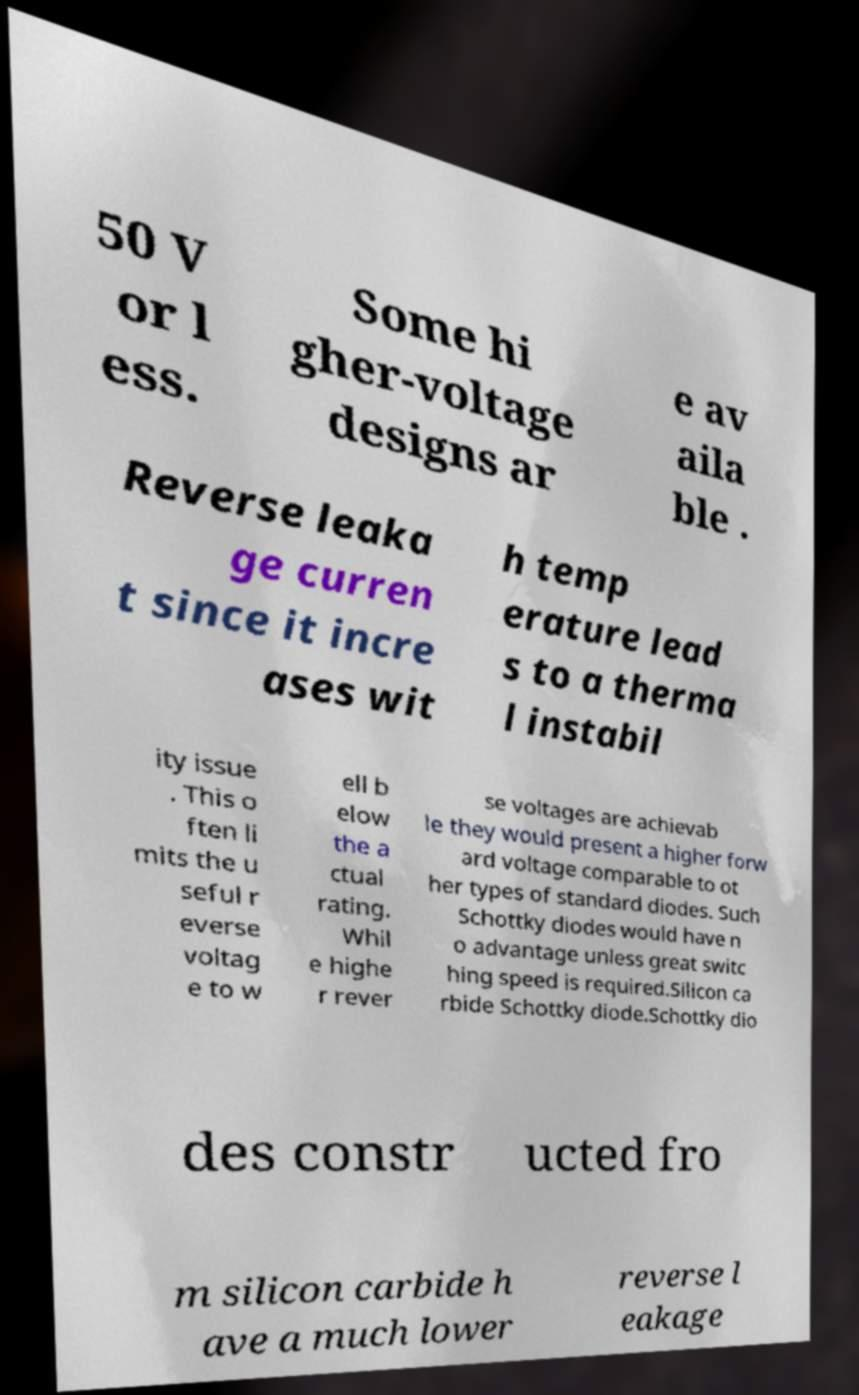I need the written content from this picture converted into text. Can you do that? 50 V or l ess. Some hi gher-voltage designs ar e av aila ble . Reverse leaka ge curren t since it incre ases wit h temp erature lead s to a therma l instabil ity issue . This o ften li mits the u seful r everse voltag e to w ell b elow the a ctual rating. Whil e highe r rever se voltages are achievab le they would present a higher forw ard voltage comparable to ot her types of standard diodes. Such Schottky diodes would have n o advantage unless great switc hing speed is required.Silicon ca rbide Schottky diode.Schottky dio des constr ucted fro m silicon carbide h ave a much lower reverse l eakage 